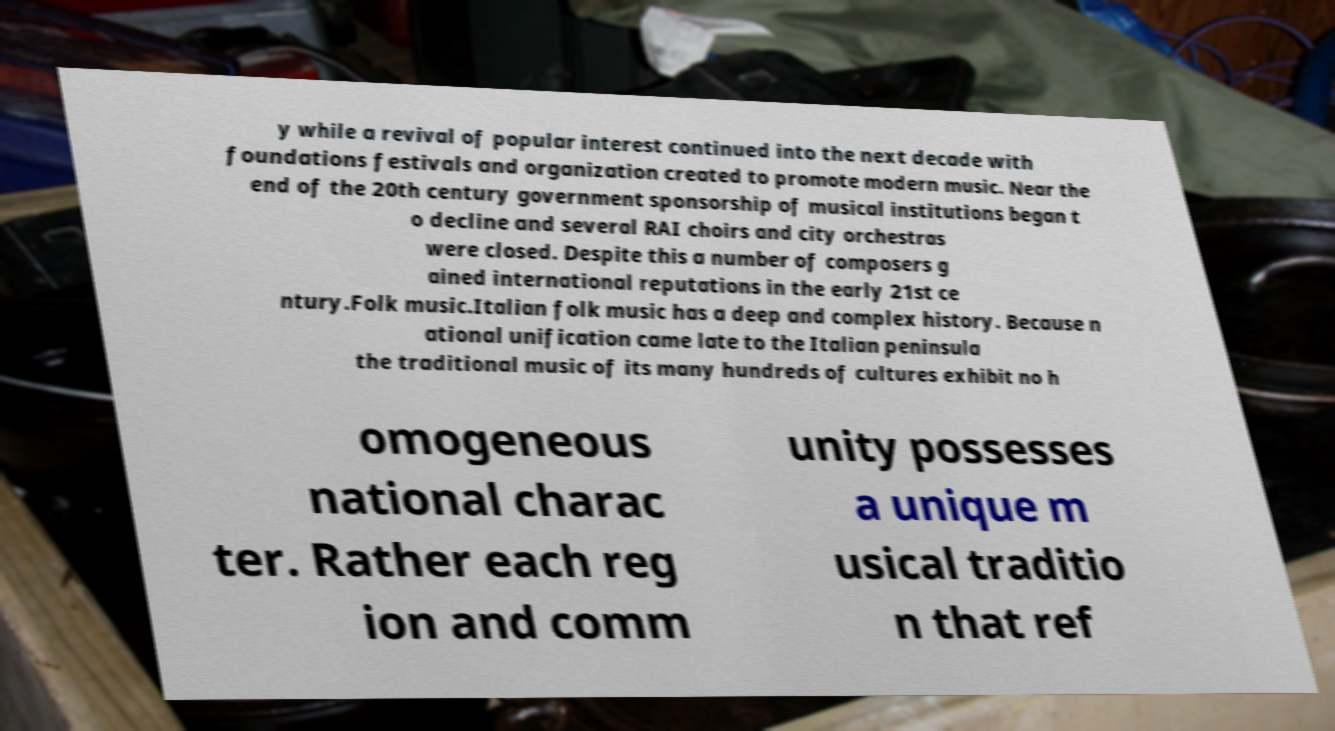For documentation purposes, I need the text within this image transcribed. Could you provide that? y while a revival of popular interest continued into the next decade with foundations festivals and organization created to promote modern music. Near the end of the 20th century government sponsorship of musical institutions began t o decline and several RAI choirs and city orchestras were closed. Despite this a number of composers g ained international reputations in the early 21st ce ntury.Folk music.Italian folk music has a deep and complex history. Because n ational unification came late to the Italian peninsula the traditional music of its many hundreds of cultures exhibit no h omogeneous national charac ter. Rather each reg ion and comm unity possesses a unique m usical traditio n that ref 